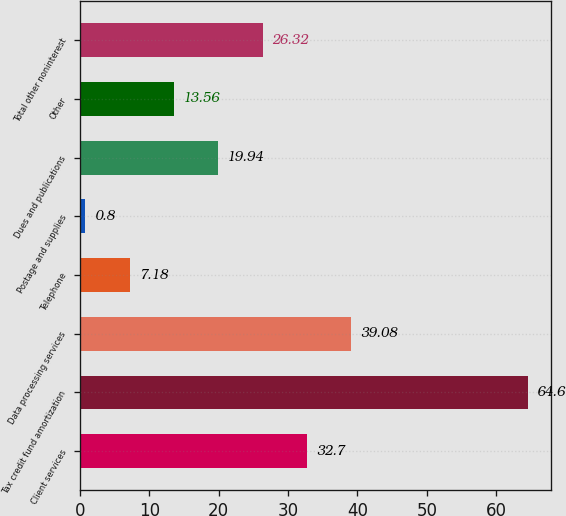Convert chart. <chart><loc_0><loc_0><loc_500><loc_500><bar_chart><fcel>Client services<fcel>Tax credit fund amortization<fcel>Data processing services<fcel>Telephone<fcel>Postage and supplies<fcel>Dues and publications<fcel>Other<fcel>Total other noninterest<nl><fcel>32.7<fcel>64.6<fcel>39.08<fcel>7.18<fcel>0.8<fcel>19.94<fcel>13.56<fcel>26.32<nl></chart> 